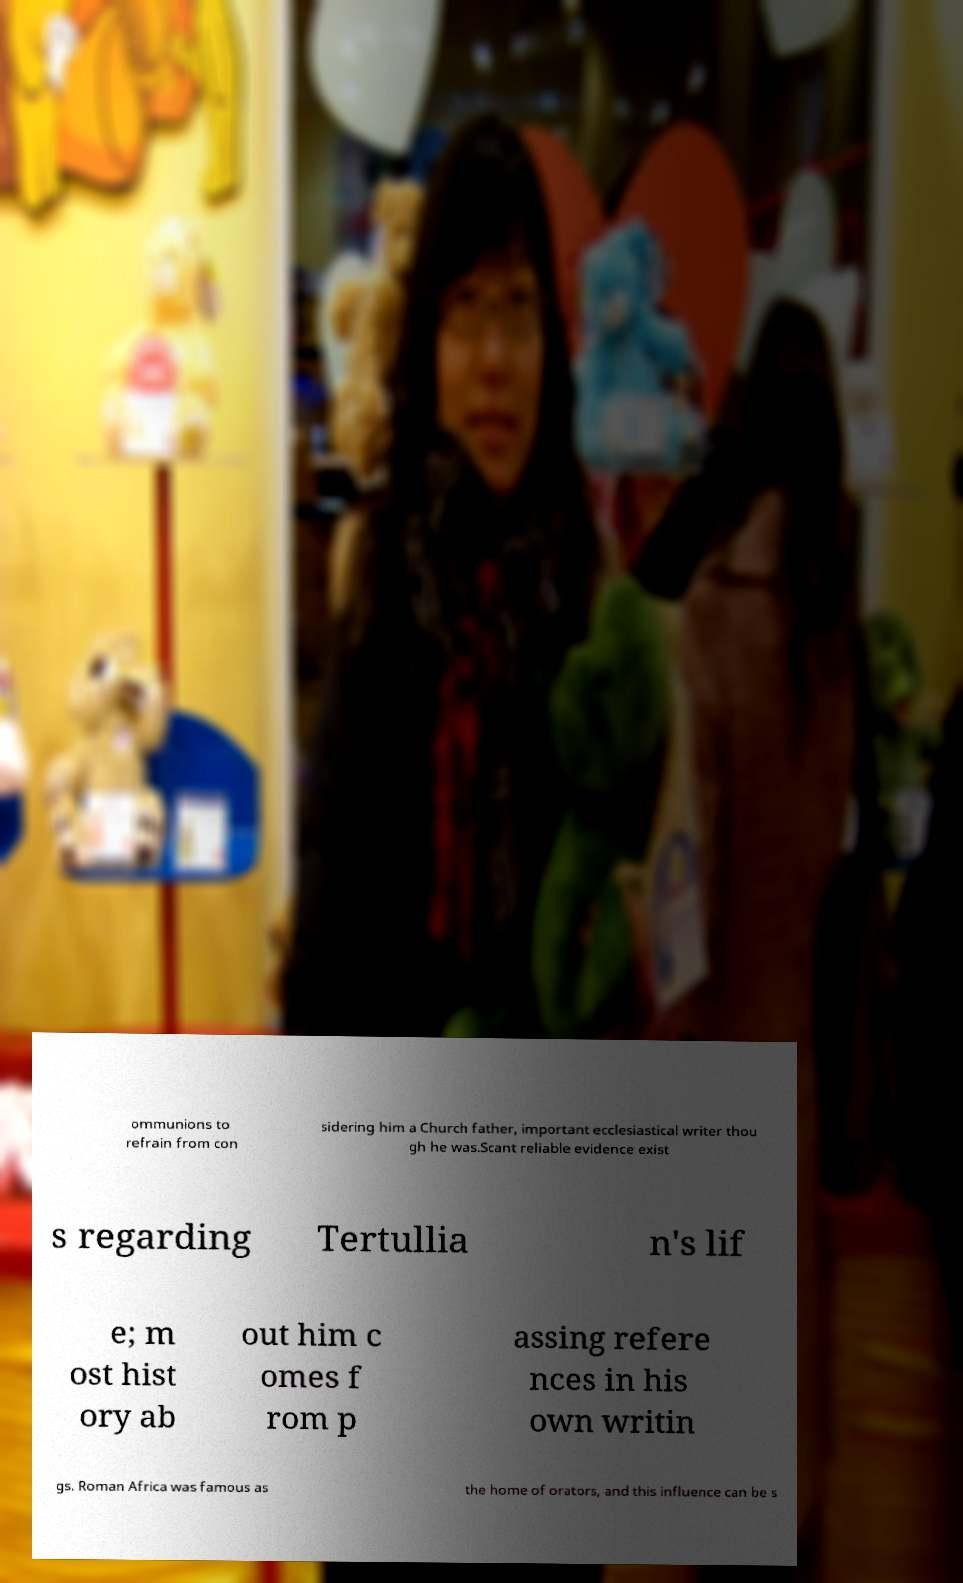For documentation purposes, I need the text within this image transcribed. Could you provide that? ommunions to refrain from con sidering him a Church father, important ecclesiastical writer thou gh he was.Scant reliable evidence exist s regarding Tertullia n's lif e; m ost hist ory ab out him c omes f rom p assing refere nces in his own writin gs. Roman Africa was famous as the home of orators, and this influence can be s 